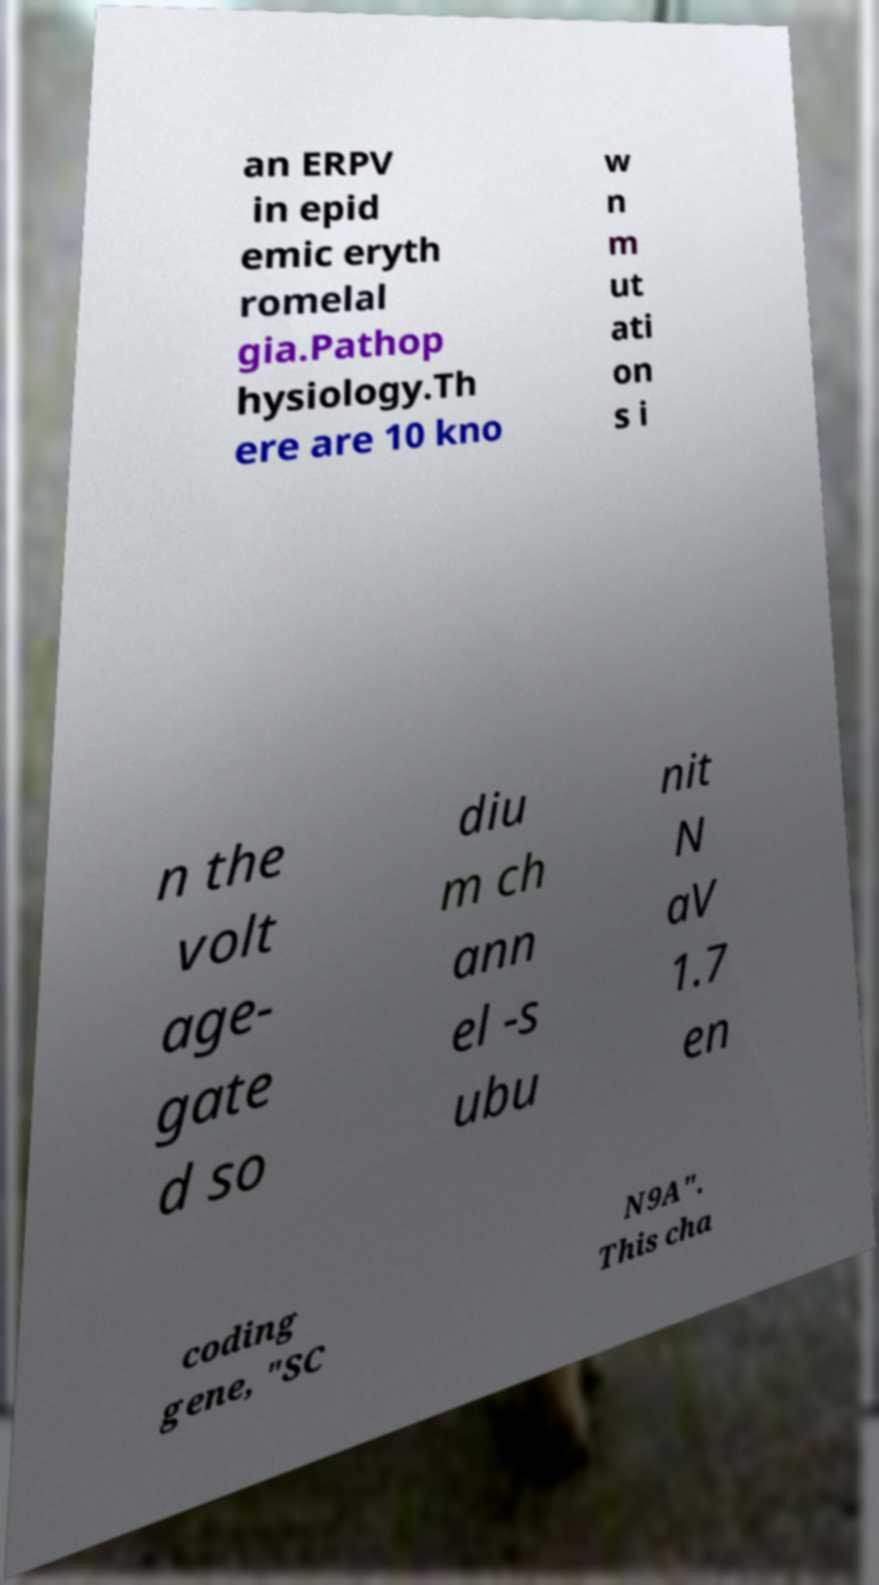For documentation purposes, I need the text within this image transcribed. Could you provide that? an ERPV in epid emic eryth romelal gia.Pathop hysiology.Th ere are 10 kno w n m ut ati on s i n the volt age- gate d so diu m ch ann el -s ubu nit N aV 1.7 en coding gene, "SC N9A". This cha 